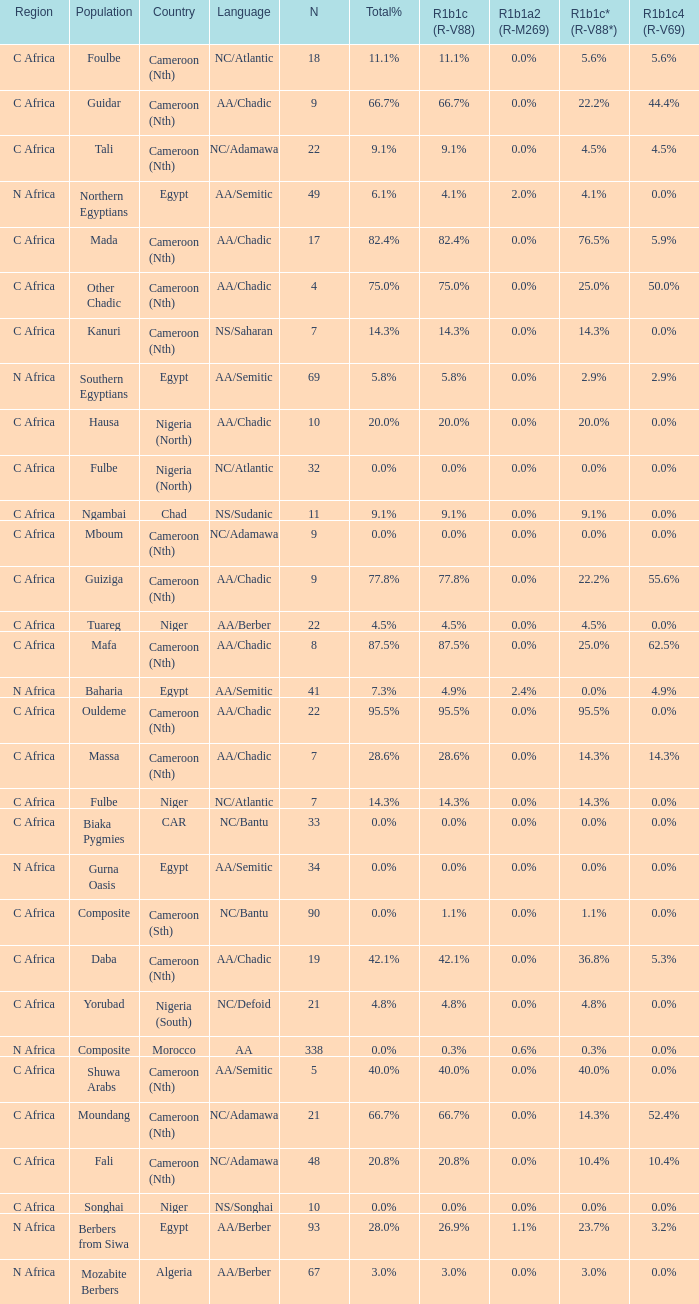What percentage is listed in column r1b1c (r-v88) for the 4.5% total percentage? 4.5%. 